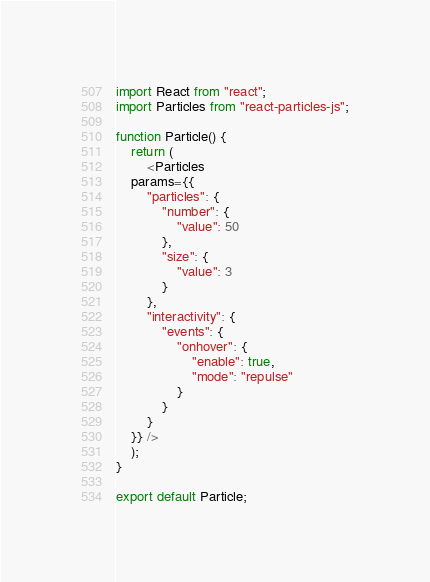Convert code to text. <code><loc_0><loc_0><loc_500><loc_500><_JavaScript_>import React from "react";
import Particles from "react-particles-js";

function Particle() {
	return (
		<Particles
    params={{
	    "particles": {
	        "number": {
	            "value": 50
	        },
	        "size": {
	            "value": 3
	        }
	    },
	    "interactivity": {
	        "events": {
	            "onhover": {
	                "enable": true,
	                "mode": "repulse"
	            }
	        }
	    }
	}} />
	);
}

export default Particle;
</code> 